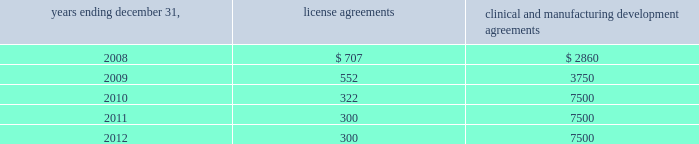Alexion pharmaceuticals , inc .
Notes to consolidated financial statements 2014 ( continued ) for the years ended december 31 , 2007 and 2006 , five month period ended december 31 , 2005 , and year ended july 31 , 2005 ( amounts in thousands , except share and per share amounts ) in 2006 , we completed a final phase iii trial of pexelizumab .
After reviewing results from that trial , we along with p&g , determined not to pursue further development of pexelizumab .
Effective march 30 , 2007 , we and p&g mutually agreed to terminate the collaboration agreement .
As the relevant agreement has been terminated in march 2007 , the remaining portion of the $ 10000 non-refundable up-front license fee , or $ 5343 , was recognized as revenue in the year ended december 31 , 2007 and is included in contract research revenues .
License and research and development agreements we have entered into a number of license , research and development and manufacturing development agreements since our inception .
These agreements have been made with various research institutions , universities , contractors , collaborators , and government agencies in order to advance and obtain technologies and services related to our business .
License agreements generally provide for an initial fee followed by annual minimum royalty payments .
Additionally , certain agreements call for future payments upon the attainment of agreed upon milestones , such as , but not limited to , investigational new drug , or ind , application or approval of biologics license application .
These agreements require minimum royalty payments based on sales of products developed from the applicable technologies , if any .
Clinical and manufacturing development agreements generally provide for us to fund manufacturing development and on-going clinical trials .
Clinical trial and development agreements include contract services and outside contractor services including contracted clinical site services related to patient enrolment for our clinical trials .
Manufacturing development agreements include clinical manufacturing and manufacturing development and scale-up .
We have executed a large-scale product supply agreement with lonza sales ag for the long-term commercial manufacture of soliris ( see note 9 ) .
In order to maintain our rights under these agreements , we may be required to provide a minimum level of funding or support .
We may elect to terminate these arrangements .
Accordingly , we recognize the expense and related obligation related to these arrangements over the period of performance .
The minimum fixed payments ( assuming non-termination of the above agreements ) as of december 31 , 2007 , for each of the next five years are as follows : years ending december 31 , license agreements clinical and manufacturing development agreements .

What is the percent change in minimum fixed payments of license agreements between 2008 and 2009? 
Computations: ((552 - 707) / 707)
Answer: -0.21924. 